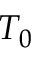<formula> <loc_0><loc_0><loc_500><loc_500>T _ { 0 }</formula> 